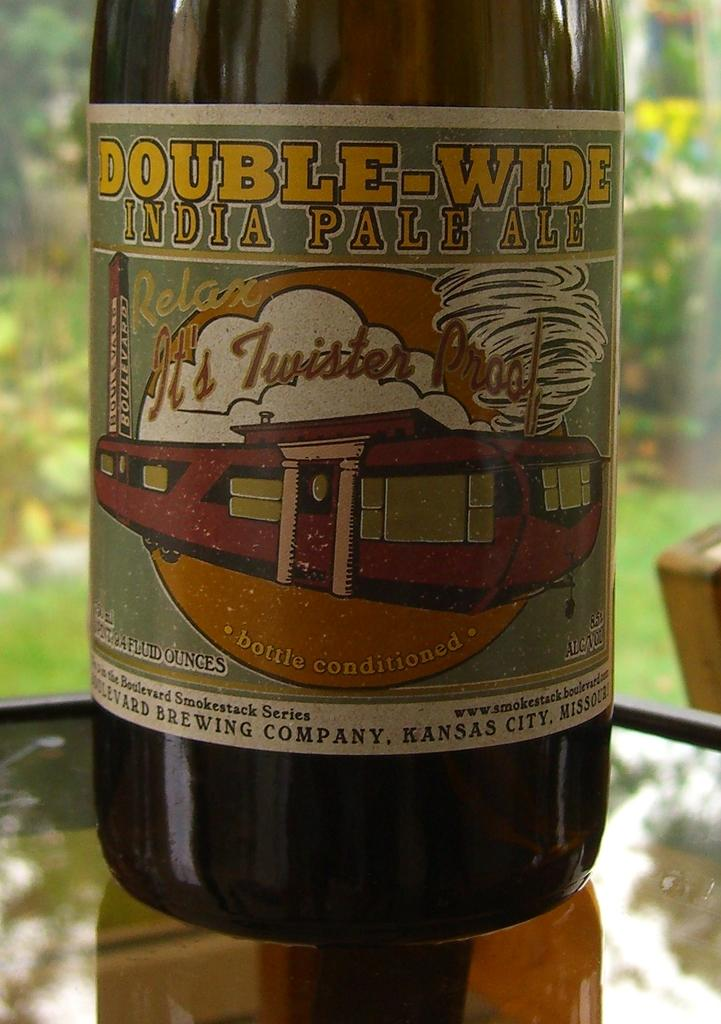<image>
Share a concise interpretation of the image provided. A bottle of beer called Double-Wide India Pale Ale and states "relax, it's twister proof" 